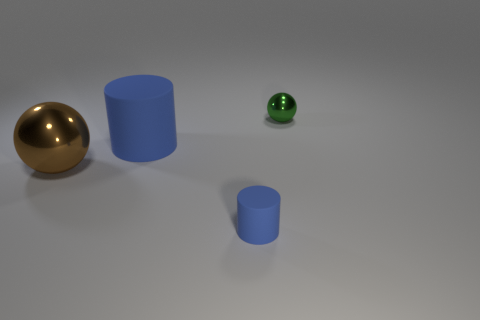Add 4 small blue metallic spheres. How many objects exist? 8 Subtract all green cylinders. Subtract all green blocks. How many cylinders are left? 2 Subtract all green cylinders. How many green balls are left? 1 Subtract all brown metal balls. Subtract all big red balls. How many objects are left? 3 Add 4 rubber objects. How many rubber objects are left? 6 Add 4 brown objects. How many brown objects exist? 5 Subtract 0 blue blocks. How many objects are left? 4 Subtract 1 cylinders. How many cylinders are left? 1 